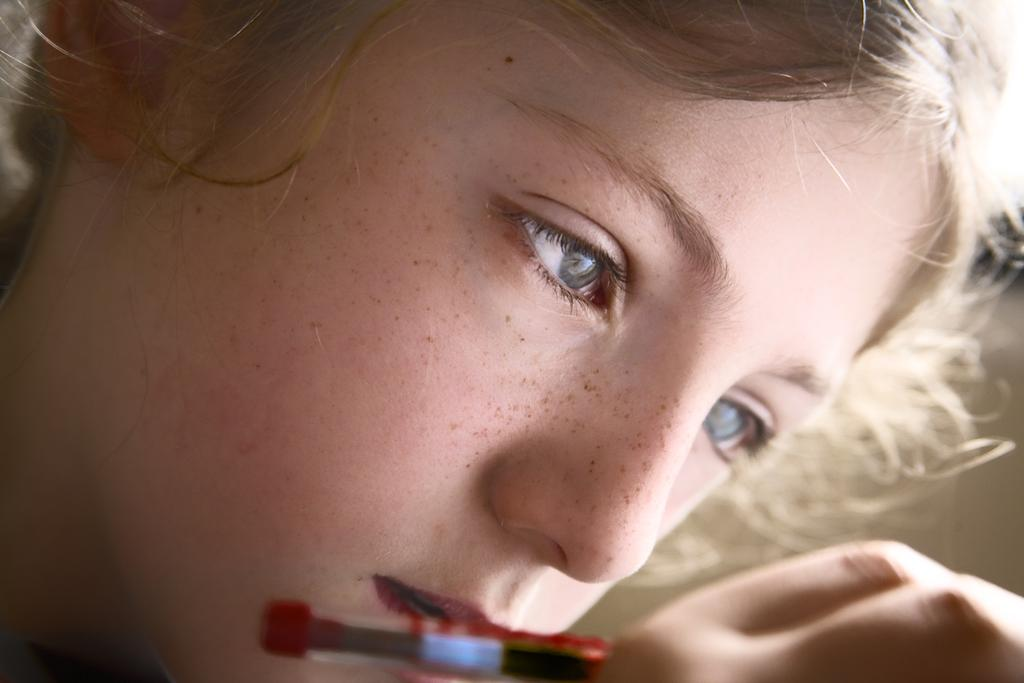Who is the main subject in the image? There is a girl in the image. What is the girl holding in the image? The girl is holding a painting brush. What type of hair is visible at the top of the image? There are hairs visible at the top of the image. What type of pen is the girl using to write in the image? There is no pen visible in the image; the girl is holding a painting brush. Are there any police officers present in the image? There is no indication of any police officers in the image. What type of seasoning is visible in the image? There is no salt or any other seasoning visible in the image. 